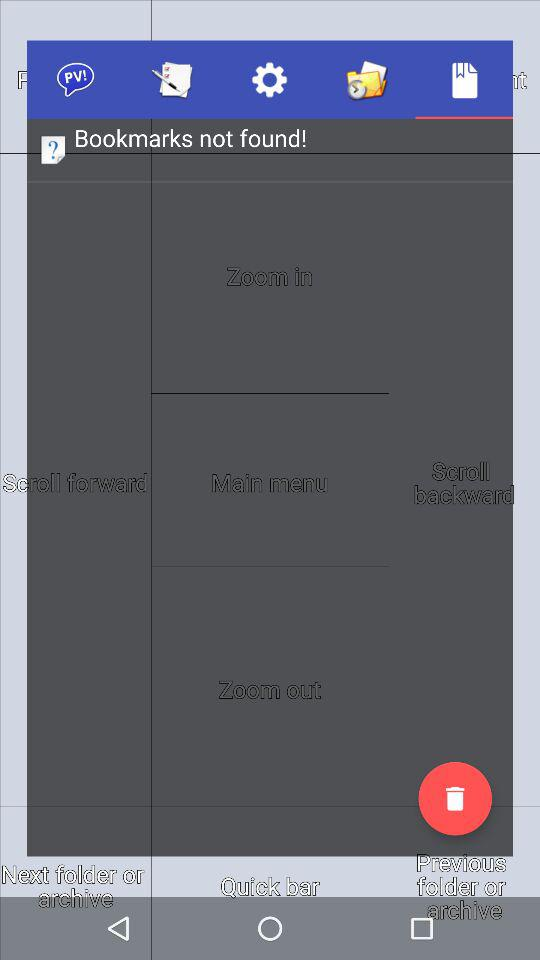If I scroll backward 10 times, how many times will I have to scroll forward to get back to the original position?
Answer the question using a single word or phrase. 10 